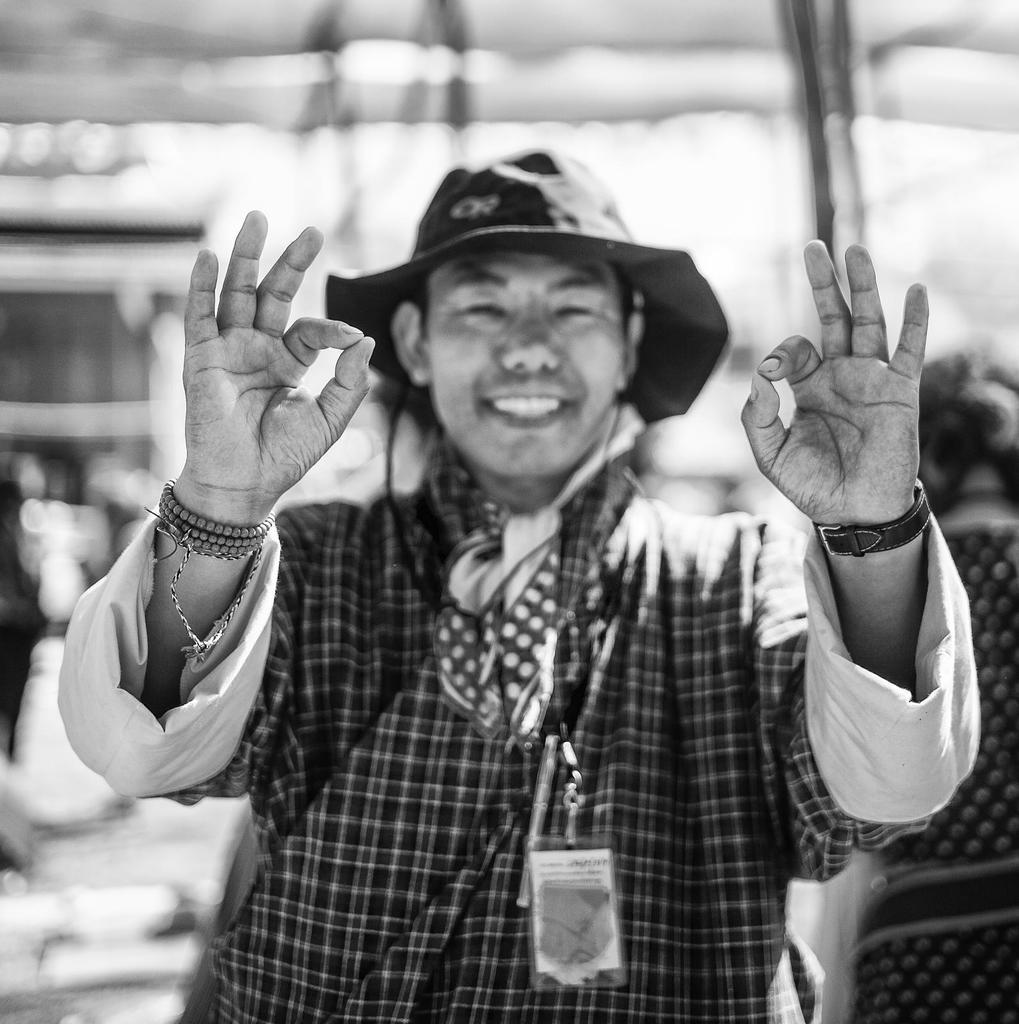What is the color scheme of the image? The image is black and white. What can be seen in the foreground of the image? There is a person standing on the road in the foreground. What is the person in the foreground wearing? The person is wearing a hat. What is visible in the background of the image? There are buildings and other persons in the background. What type of muscle is being exercised by the person in the image? There is no indication in the image of the person exercising any muscles, as they are simply standing on the road. Is there any sleet visible in the image? There is no mention of sleet or any weather conditions in the provided facts, so it cannot be determined from the image. 